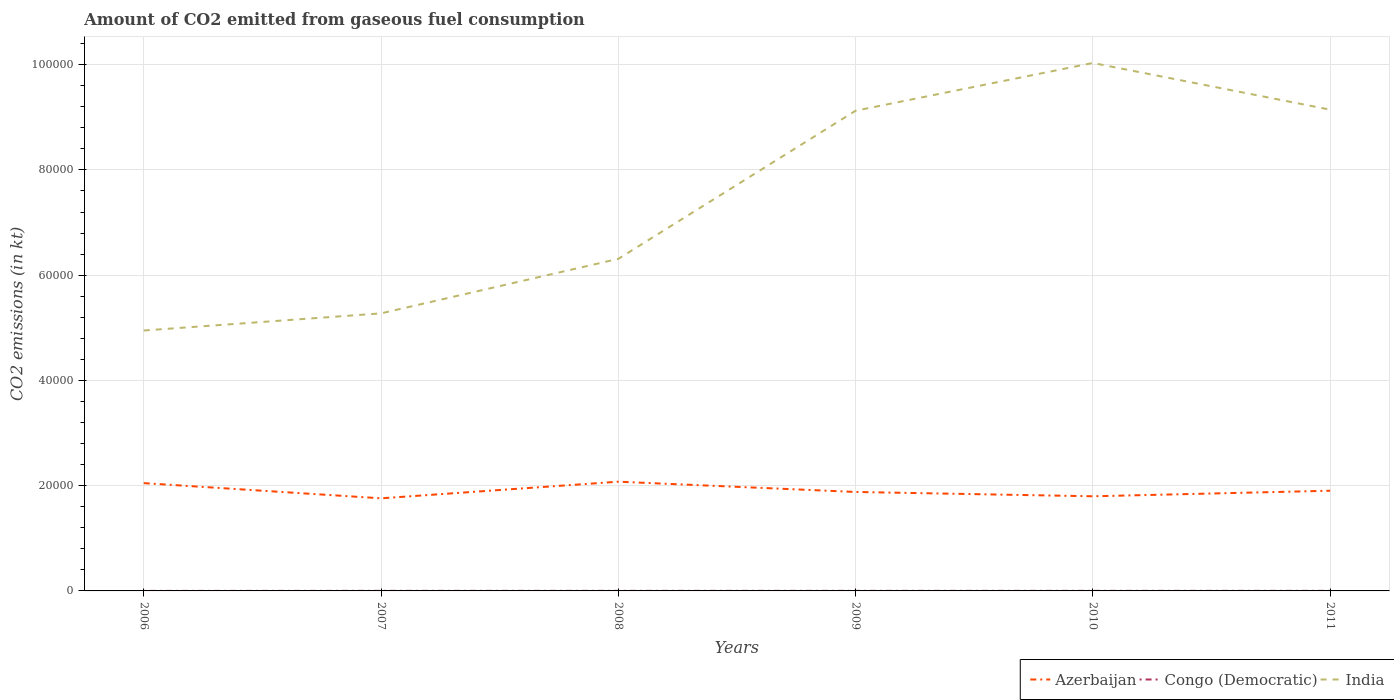How many different coloured lines are there?
Give a very brief answer. 3. Is the number of lines equal to the number of legend labels?
Offer a very short reply. Yes. Across all years, what is the maximum amount of CO2 emitted in India?
Your answer should be compact. 4.95e+04. In which year was the amount of CO2 emitted in Congo (Democratic) maximum?
Your answer should be compact. 2006. What is the total amount of CO2 emitted in India in the graph?
Your answer should be compact. -4.20e+04. What is the difference between the highest and the second highest amount of CO2 emitted in Congo (Democratic)?
Give a very brief answer. 7.33. Are the values on the major ticks of Y-axis written in scientific E-notation?
Provide a short and direct response. No. Does the graph contain any zero values?
Your answer should be compact. No. Does the graph contain grids?
Give a very brief answer. Yes. Where does the legend appear in the graph?
Make the answer very short. Bottom right. How many legend labels are there?
Your answer should be very brief. 3. What is the title of the graph?
Make the answer very short. Amount of CO2 emitted from gaseous fuel consumption. Does "Sweden" appear as one of the legend labels in the graph?
Make the answer very short. No. What is the label or title of the Y-axis?
Your response must be concise. CO2 emissions (in kt). What is the CO2 emissions (in kt) in Azerbaijan in 2006?
Make the answer very short. 2.05e+04. What is the CO2 emissions (in kt) in Congo (Democratic) in 2006?
Ensure brevity in your answer.  7.33. What is the CO2 emissions (in kt) in India in 2006?
Provide a short and direct response. 4.95e+04. What is the CO2 emissions (in kt) in Azerbaijan in 2007?
Ensure brevity in your answer.  1.76e+04. What is the CO2 emissions (in kt) of Congo (Democratic) in 2007?
Your answer should be compact. 14.67. What is the CO2 emissions (in kt) of India in 2007?
Offer a very short reply. 5.27e+04. What is the CO2 emissions (in kt) of Azerbaijan in 2008?
Offer a very short reply. 2.08e+04. What is the CO2 emissions (in kt) in Congo (Democratic) in 2008?
Offer a terse response. 14.67. What is the CO2 emissions (in kt) in India in 2008?
Ensure brevity in your answer.  6.31e+04. What is the CO2 emissions (in kt) in Azerbaijan in 2009?
Your response must be concise. 1.88e+04. What is the CO2 emissions (in kt) in Congo (Democratic) in 2009?
Your answer should be compact. 14.67. What is the CO2 emissions (in kt) of India in 2009?
Offer a very short reply. 9.12e+04. What is the CO2 emissions (in kt) in Azerbaijan in 2010?
Provide a short and direct response. 1.80e+04. What is the CO2 emissions (in kt) in Congo (Democratic) in 2010?
Offer a very short reply. 14.67. What is the CO2 emissions (in kt) of India in 2010?
Give a very brief answer. 1.00e+05. What is the CO2 emissions (in kt) of Azerbaijan in 2011?
Your answer should be compact. 1.90e+04. What is the CO2 emissions (in kt) of Congo (Democratic) in 2011?
Your response must be concise. 14.67. What is the CO2 emissions (in kt) of India in 2011?
Offer a terse response. 9.14e+04. Across all years, what is the maximum CO2 emissions (in kt) in Azerbaijan?
Make the answer very short. 2.08e+04. Across all years, what is the maximum CO2 emissions (in kt) in Congo (Democratic)?
Make the answer very short. 14.67. Across all years, what is the maximum CO2 emissions (in kt) of India?
Ensure brevity in your answer.  1.00e+05. Across all years, what is the minimum CO2 emissions (in kt) of Azerbaijan?
Keep it short and to the point. 1.76e+04. Across all years, what is the minimum CO2 emissions (in kt) of Congo (Democratic)?
Make the answer very short. 7.33. Across all years, what is the minimum CO2 emissions (in kt) in India?
Give a very brief answer. 4.95e+04. What is the total CO2 emissions (in kt) of Azerbaijan in the graph?
Offer a very short reply. 1.15e+05. What is the total CO2 emissions (in kt) of Congo (Democratic) in the graph?
Your answer should be compact. 80.67. What is the total CO2 emissions (in kt) in India in the graph?
Your response must be concise. 4.48e+05. What is the difference between the CO2 emissions (in kt) in Azerbaijan in 2006 and that in 2007?
Provide a succinct answer. 2889.6. What is the difference between the CO2 emissions (in kt) of Congo (Democratic) in 2006 and that in 2007?
Your answer should be compact. -7.33. What is the difference between the CO2 emissions (in kt) of India in 2006 and that in 2007?
Your answer should be very brief. -3256.3. What is the difference between the CO2 emissions (in kt) in Azerbaijan in 2006 and that in 2008?
Offer a very short reply. -271.36. What is the difference between the CO2 emissions (in kt) in Congo (Democratic) in 2006 and that in 2008?
Make the answer very short. -7.33. What is the difference between the CO2 emissions (in kt) of India in 2006 and that in 2008?
Ensure brevity in your answer.  -1.36e+04. What is the difference between the CO2 emissions (in kt) of Azerbaijan in 2006 and that in 2009?
Your answer should be compact. 1679.49. What is the difference between the CO2 emissions (in kt) of Congo (Democratic) in 2006 and that in 2009?
Offer a very short reply. -7.33. What is the difference between the CO2 emissions (in kt) in India in 2006 and that in 2009?
Give a very brief answer. -4.18e+04. What is the difference between the CO2 emissions (in kt) of Azerbaijan in 2006 and that in 2010?
Provide a succinct answer. 2500.89. What is the difference between the CO2 emissions (in kt) of Congo (Democratic) in 2006 and that in 2010?
Give a very brief answer. -7.33. What is the difference between the CO2 emissions (in kt) of India in 2006 and that in 2010?
Provide a succinct answer. -5.08e+04. What is the difference between the CO2 emissions (in kt) in Azerbaijan in 2006 and that in 2011?
Your response must be concise. 1444.8. What is the difference between the CO2 emissions (in kt) of Congo (Democratic) in 2006 and that in 2011?
Give a very brief answer. -7.33. What is the difference between the CO2 emissions (in kt) in India in 2006 and that in 2011?
Give a very brief answer. -4.20e+04. What is the difference between the CO2 emissions (in kt) in Azerbaijan in 2007 and that in 2008?
Offer a terse response. -3160.95. What is the difference between the CO2 emissions (in kt) of India in 2007 and that in 2008?
Keep it short and to the point. -1.04e+04. What is the difference between the CO2 emissions (in kt) of Azerbaijan in 2007 and that in 2009?
Offer a terse response. -1210.11. What is the difference between the CO2 emissions (in kt) of Congo (Democratic) in 2007 and that in 2009?
Provide a succinct answer. 0. What is the difference between the CO2 emissions (in kt) in India in 2007 and that in 2009?
Offer a terse response. -3.85e+04. What is the difference between the CO2 emissions (in kt) in Azerbaijan in 2007 and that in 2010?
Keep it short and to the point. -388.7. What is the difference between the CO2 emissions (in kt) in Congo (Democratic) in 2007 and that in 2010?
Your response must be concise. 0. What is the difference between the CO2 emissions (in kt) in India in 2007 and that in 2010?
Keep it short and to the point. -4.76e+04. What is the difference between the CO2 emissions (in kt) in Azerbaijan in 2007 and that in 2011?
Ensure brevity in your answer.  -1444.8. What is the difference between the CO2 emissions (in kt) in Congo (Democratic) in 2007 and that in 2011?
Ensure brevity in your answer.  0. What is the difference between the CO2 emissions (in kt) of India in 2007 and that in 2011?
Ensure brevity in your answer.  -3.87e+04. What is the difference between the CO2 emissions (in kt) of Azerbaijan in 2008 and that in 2009?
Give a very brief answer. 1950.84. What is the difference between the CO2 emissions (in kt) of Congo (Democratic) in 2008 and that in 2009?
Provide a succinct answer. 0. What is the difference between the CO2 emissions (in kt) in India in 2008 and that in 2009?
Ensure brevity in your answer.  -2.81e+04. What is the difference between the CO2 emissions (in kt) in Azerbaijan in 2008 and that in 2010?
Make the answer very short. 2772.25. What is the difference between the CO2 emissions (in kt) of India in 2008 and that in 2010?
Provide a succinct answer. -3.72e+04. What is the difference between the CO2 emissions (in kt) of Azerbaijan in 2008 and that in 2011?
Give a very brief answer. 1716.16. What is the difference between the CO2 emissions (in kt) in India in 2008 and that in 2011?
Offer a terse response. -2.83e+04. What is the difference between the CO2 emissions (in kt) of Azerbaijan in 2009 and that in 2010?
Your answer should be very brief. 821.41. What is the difference between the CO2 emissions (in kt) of India in 2009 and that in 2010?
Provide a succinct answer. -9072.16. What is the difference between the CO2 emissions (in kt) in Azerbaijan in 2009 and that in 2011?
Provide a short and direct response. -234.69. What is the difference between the CO2 emissions (in kt) in India in 2009 and that in 2011?
Provide a succinct answer. -198.02. What is the difference between the CO2 emissions (in kt) of Azerbaijan in 2010 and that in 2011?
Your answer should be very brief. -1056.1. What is the difference between the CO2 emissions (in kt) of Congo (Democratic) in 2010 and that in 2011?
Offer a very short reply. 0. What is the difference between the CO2 emissions (in kt) in India in 2010 and that in 2011?
Give a very brief answer. 8874.14. What is the difference between the CO2 emissions (in kt) in Azerbaijan in 2006 and the CO2 emissions (in kt) in Congo (Democratic) in 2007?
Offer a terse response. 2.05e+04. What is the difference between the CO2 emissions (in kt) of Azerbaijan in 2006 and the CO2 emissions (in kt) of India in 2007?
Give a very brief answer. -3.23e+04. What is the difference between the CO2 emissions (in kt) of Congo (Democratic) in 2006 and the CO2 emissions (in kt) of India in 2007?
Ensure brevity in your answer.  -5.27e+04. What is the difference between the CO2 emissions (in kt) in Azerbaijan in 2006 and the CO2 emissions (in kt) in Congo (Democratic) in 2008?
Offer a terse response. 2.05e+04. What is the difference between the CO2 emissions (in kt) in Azerbaijan in 2006 and the CO2 emissions (in kt) in India in 2008?
Offer a terse response. -4.26e+04. What is the difference between the CO2 emissions (in kt) in Congo (Democratic) in 2006 and the CO2 emissions (in kt) in India in 2008?
Provide a short and direct response. -6.31e+04. What is the difference between the CO2 emissions (in kt) in Azerbaijan in 2006 and the CO2 emissions (in kt) in Congo (Democratic) in 2009?
Offer a terse response. 2.05e+04. What is the difference between the CO2 emissions (in kt) in Azerbaijan in 2006 and the CO2 emissions (in kt) in India in 2009?
Your answer should be compact. -7.08e+04. What is the difference between the CO2 emissions (in kt) in Congo (Democratic) in 2006 and the CO2 emissions (in kt) in India in 2009?
Make the answer very short. -9.12e+04. What is the difference between the CO2 emissions (in kt) of Azerbaijan in 2006 and the CO2 emissions (in kt) of Congo (Democratic) in 2010?
Your answer should be very brief. 2.05e+04. What is the difference between the CO2 emissions (in kt) of Azerbaijan in 2006 and the CO2 emissions (in kt) of India in 2010?
Keep it short and to the point. -7.98e+04. What is the difference between the CO2 emissions (in kt) of Congo (Democratic) in 2006 and the CO2 emissions (in kt) of India in 2010?
Provide a succinct answer. -1.00e+05. What is the difference between the CO2 emissions (in kt) of Azerbaijan in 2006 and the CO2 emissions (in kt) of Congo (Democratic) in 2011?
Give a very brief answer. 2.05e+04. What is the difference between the CO2 emissions (in kt) in Azerbaijan in 2006 and the CO2 emissions (in kt) in India in 2011?
Your response must be concise. -7.10e+04. What is the difference between the CO2 emissions (in kt) in Congo (Democratic) in 2006 and the CO2 emissions (in kt) in India in 2011?
Provide a short and direct response. -9.14e+04. What is the difference between the CO2 emissions (in kt) in Azerbaijan in 2007 and the CO2 emissions (in kt) in Congo (Democratic) in 2008?
Offer a terse response. 1.76e+04. What is the difference between the CO2 emissions (in kt) of Azerbaijan in 2007 and the CO2 emissions (in kt) of India in 2008?
Your response must be concise. -4.55e+04. What is the difference between the CO2 emissions (in kt) in Congo (Democratic) in 2007 and the CO2 emissions (in kt) in India in 2008?
Your response must be concise. -6.31e+04. What is the difference between the CO2 emissions (in kt) in Azerbaijan in 2007 and the CO2 emissions (in kt) in Congo (Democratic) in 2009?
Give a very brief answer. 1.76e+04. What is the difference between the CO2 emissions (in kt) of Azerbaijan in 2007 and the CO2 emissions (in kt) of India in 2009?
Give a very brief answer. -7.37e+04. What is the difference between the CO2 emissions (in kt) in Congo (Democratic) in 2007 and the CO2 emissions (in kt) in India in 2009?
Your answer should be very brief. -9.12e+04. What is the difference between the CO2 emissions (in kt) in Azerbaijan in 2007 and the CO2 emissions (in kt) in Congo (Democratic) in 2010?
Keep it short and to the point. 1.76e+04. What is the difference between the CO2 emissions (in kt) in Azerbaijan in 2007 and the CO2 emissions (in kt) in India in 2010?
Ensure brevity in your answer.  -8.27e+04. What is the difference between the CO2 emissions (in kt) of Congo (Democratic) in 2007 and the CO2 emissions (in kt) of India in 2010?
Your answer should be compact. -1.00e+05. What is the difference between the CO2 emissions (in kt) in Azerbaijan in 2007 and the CO2 emissions (in kt) in Congo (Democratic) in 2011?
Provide a short and direct response. 1.76e+04. What is the difference between the CO2 emissions (in kt) in Azerbaijan in 2007 and the CO2 emissions (in kt) in India in 2011?
Offer a very short reply. -7.38e+04. What is the difference between the CO2 emissions (in kt) of Congo (Democratic) in 2007 and the CO2 emissions (in kt) of India in 2011?
Your answer should be compact. -9.14e+04. What is the difference between the CO2 emissions (in kt) in Azerbaijan in 2008 and the CO2 emissions (in kt) in Congo (Democratic) in 2009?
Make the answer very short. 2.07e+04. What is the difference between the CO2 emissions (in kt) of Azerbaijan in 2008 and the CO2 emissions (in kt) of India in 2009?
Your response must be concise. -7.05e+04. What is the difference between the CO2 emissions (in kt) of Congo (Democratic) in 2008 and the CO2 emissions (in kt) of India in 2009?
Ensure brevity in your answer.  -9.12e+04. What is the difference between the CO2 emissions (in kt) of Azerbaijan in 2008 and the CO2 emissions (in kt) of Congo (Democratic) in 2010?
Make the answer very short. 2.07e+04. What is the difference between the CO2 emissions (in kt) in Azerbaijan in 2008 and the CO2 emissions (in kt) in India in 2010?
Keep it short and to the point. -7.96e+04. What is the difference between the CO2 emissions (in kt) of Congo (Democratic) in 2008 and the CO2 emissions (in kt) of India in 2010?
Ensure brevity in your answer.  -1.00e+05. What is the difference between the CO2 emissions (in kt) of Azerbaijan in 2008 and the CO2 emissions (in kt) of Congo (Democratic) in 2011?
Provide a short and direct response. 2.07e+04. What is the difference between the CO2 emissions (in kt) of Azerbaijan in 2008 and the CO2 emissions (in kt) of India in 2011?
Offer a terse response. -7.07e+04. What is the difference between the CO2 emissions (in kt) of Congo (Democratic) in 2008 and the CO2 emissions (in kt) of India in 2011?
Offer a very short reply. -9.14e+04. What is the difference between the CO2 emissions (in kt) in Azerbaijan in 2009 and the CO2 emissions (in kt) in Congo (Democratic) in 2010?
Ensure brevity in your answer.  1.88e+04. What is the difference between the CO2 emissions (in kt) in Azerbaijan in 2009 and the CO2 emissions (in kt) in India in 2010?
Your answer should be compact. -8.15e+04. What is the difference between the CO2 emissions (in kt) of Congo (Democratic) in 2009 and the CO2 emissions (in kt) of India in 2010?
Provide a succinct answer. -1.00e+05. What is the difference between the CO2 emissions (in kt) in Azerbaijan in 2009 and the CO2 emissions (in kt) in Congo (Democratic) in 2011?
Your answer should be very brief. 1.88e+04. What is the difference between the CO2 emissions (in kt) of Azerbaijan in 2009 and the CO2 emissions (in kt) of India in 2011?
Provide a short and direct response. -7.26e+04. What is the difference between the CO2 emissions (in kt) in Congo (Democratic) in 2009 and the CO2 emissions (in kt) in India in 2011?
Make the answer very short. -9.14e+04. What is the difference between the CO2 emissions (in kt) in Azerbaijan in 2010 and the CO2 emissions (in kt) in Congo (Democratic) in 2011?
Ensure brevity in your answer.  1.80e+04. What is the difference between the CO2 emissions (in kt) of Azerbaijan in 2010 and the CO2 emissions (in kt) of India in 2011?
Keep it short and to the point. -7.35e+04. What is the difference between the CO2 emissions (in kt) in Congo (Democratic) in 2010 and the CO2 emissions (in kt) in India in 2011?
Give a very brief answer. -9.14e+04. What is the average CO2 emissions (in kt) of Azerbaijan per year?
Your response must be concise. 1.91e+04. What is the average CO2 emissions (in kt) of Congo (Democratic) per year?
Your response must be concise. 13.45. What is the average CO2 emissions (in kt) of India per year?
Your response must be concise. 7.47e+04. In the year 2006, what is the difference between the CO2 emissions (in kt) of Azerbaijan and CO2 emissions (in kt) of Congo (Democratic)?
Offer a terse response. 2.05e+04. In the year 2006, what is the difference between the CO2 emissions (in kt) of Azerbaijan and CO2 emissions (in kt) of India?
Offer a terse response. -2.90e+04. In the year 2006, what is the difference between the CO2 emissions (in kt) of Congo (Democratic) and CO2 emissions (in kt) of India?
Ensure brevity in your answer.  -4.95e+04. In the year 2007, what is the difference between the CO2 emissions (in kt) in Azerbaijan and CO2 emissions (in kt) in Congo (Democratic)?
Offer a very short reply. 1.76e+04. In the year 2007, what is the difference between the CO2 emissions (in kt) of Azerbaijan and CO2 emissions (in kt) of India?
Provide a short and direct response. -3.51e+04. In the year 2007, what is the difference between the CO2 emissions (in kt) of Congo (Democratic) and CO2 emissions (in kt) of India?
Offer a terse response. -5.27e+04. In the year 2008, what is the difference between the CO2 emissions (in kt) of Azerbaijan and CO2 emissions (in kt) of Congo (Democratic)?
Keep it short and to the point. 2.07e+04. In the year 2008, what is the difference between the CO2 emissions (in kt) in Azerbaijan and CO2 emissions (in kt) in India?
Ensure brevity in your answer.  -4.23e+04. In the year 2008, what is the difference between the CO2 emissions (in kt) in Congo (Democratic) and CO2 emissions (in kt) in India?
Your response must be concise. -6.31e+04. In the year 2009, what is the difference between the CO2 emissions (in kt) of Azerbaijan and CO2 emissions (in kt) of Congo (Democratic)?
Provide a succinct answer. 1.88e+04. In the year 2009, what is the difference between the CO2 emissions (in kt) of Azerbaijan and CO2 emissions (in kt) of India?
Give a very brief answer. -7.24e+04. In the year 2009, what is the difference between the CO2 emissions (in kt) in Congo (Democratic) and CO2 emissions (in kt) in India?
Ensure brevity in your answer.  -9.12e+04. In the year 2010, what is the difference between the CO2 emissions (in kt) in Azerbaijan and CO2 emissions (in kt) in Congo (Democratic)?
Offer a very short reply. 1.80e+04. In the year 2010, what is the difference between the CO2 emissions (in kt) of Azerbaijan and CO2 emissions (in kt) of India?
Ensure brevity in your answer.  -8.23e+04. In the year 2010, what is the difference between the CO2 emissions (in kt) in Congo (Democratic) and CO2 emissions (in kt) in India?
Keep it short and to the point. -1.00e+05. In the year 2011, what is the difference between the CO2 emissions (in kt) of Azerbaijan and CO2 emissions (in kt) of Congo (Democratic)?
Your answer should be very brief. 1.90e+04. In the year 2011, what is the difference between the CO2 emissions (in kt) of Azerbaijan and CO2 emissions (in kt) of India?
Make the answer very short. -7.24e+04. In the year 2011, what is the difference between the CO2 emissions (in kt) of Congo (Democratic) and CO2 emissions (in kt) of India?
Your answer should be compact. -9.14e+04. What is the ratio of the CO2 emissions (in kt) in Azerbaijan in 2006 to that in 2007?
Provide a short and direct response. 1.16. What is the ratio of the CO2 emissions (in kt) in Congo (Democratic) in 2006 to that in 2007?
Give a very brief answer. 0.5. What is the ratio of the CO2 emissions (in kt) in India in 2006 to that in 2007?
Provide a succinct answer. 0.94. What is the ratio of the CO2 emissions (in kt) of Azerbaijan in 2006 to that in 2008?
Keep it short and to the point. 0.99. What is the ratio of the CO2 emissions (in kt) of India in 2006 to that in 2008?
Ensure brevity in your answer.  0.78. What is the ratio of the CO2 emissions (in kt) of Azerbaijan in 2006 to that in 2009?
Give a very brief answer. 1.09. What is the ratio of the CO2 emissions (in kt) in Congo (Democratic) in 2006 to that in 2009?
Your response must be concise. 0.5. What is the ratio of the CO2 emissions (in kt) of India in 2006 to that in 2009?
Your response must be concise. 0.54. What is the ratio of the CO2 emissions (in kt) of Azerbaijan in 2006 to that in 2010?
Ensure brevity in your answer.  1.14. What is the ratio of the CO2 emissions (in kt) of India in 2006 to that in 2010?
Offer a very short reply. 0.49. What is the ratio of the CO2 emissions (in kt) of Azerbaijan in 2006 to that in 2011?
Give a very brief answer. 1.08. What is the ratio of the CO2 emissions (in kt) of Congo (Democratic) in 2006 to that in 2011?
Your response must be concise. 0.5. What is the ratio of the CO2 emissions (in kt) of India in 2006 to that in 2011?
Make the answer very short. 0.54. What is the ratio of the CO2 emissions (in kt) in Azerbaijan in 2007 to that in 2008?
Keep it short and to the point. 0.85. What is the ratio of the CO2 emissions (in kt) of India in 2007 to that in 2008?
Provide a short and direct response. 0.84. What is the ratio of the CO2 emissions (in kt) of Azerbaijan in 2007 to that in 2009?
Offer a very short reply. 0.94. What is the ratio of the CO2 emissions (in kt) in Congo (Democratic) in 2007 to that in 2009?
Provide a succinct answer. 1. What is the ratio of the CO2 emissions (in kt) in India in 2007 to that in 2009?
Provide a short and direct response. 0.58. What is the ratio of the CO2 emissions (in kt) of Azerbaijan in 2007 to that in 2010?
Give a very brief answer. 0.98. What is the ratio of the CO2 emissions (in kt) of Congo (Democratic) in 2007 to that in 2010?
Your answer should be very brief. 1. What is the ratio of the CO2 emissions (in kt) in India in 2007 to that in 2010?
Provide a short and direct response. 0.53. What is the ratio of the CO2 emissions (in kt) of Azerbaijan in 2007 to that in 2011?
Offer a terse response. 0.92. What is the ratio of the CO2 emissions (in kt) in Congo (Democratic) in 2007 to that in 2011?
Make the answer very short. 1. What is the ratio of the CO2 emissions (in kt) of India in 2007 to that in 2011?
Your response must be concise. 0.58. What is the ratio of the CO2 emissions (in kt) in Azerbaijan in 2008 to that in 2009?
Offer a terse response. 1.1. What is the ratio of the CO2 emissions (in kt) in India in 2008 to that in 2009?
Give a very brief answer. 0.69. What is the ratio of the CO2 emissions (in kt) in Azerbaijan in 2008 to that in 2010?
Your answer should be compact. 1.15. What is the ratio of the CO2 emissions (in kt) of Congo (Democratic) in 2008 to that in 2010?
Keep it short and to the point. 1. What is the ratio of the CO2 emissions (in kt) in India in 2008 to that in 2010?
Your answer should be compact. 0.63. What is the ratio of the CO2 emissions (in kt) in Azerbaijan in 2008 to that in 2011?
Keep it short and to the point. 1.09. What is the ratio of the CO2 emissions (in kt) in Congo (Democratic) in 2008 to that in 2011?
Offer a very short reply. 1. What is the ratio of the CO2 emissions (in kt) of India in 2008 to that in 2011?
Your answer should be very brief. 0.69. What is the ratio of the CO2 emissions (in kt) in Azerbaijan in 2009 to that in 2010?
Ensure brevity in your answer.  1.05. What is the ratio of the CO2 emissions (in kt) in India in 2009 to that in 2010?
Provide a succinct answer. 0.91. What is the ratio of the CO2 emissions (in kt) of India in 2009 to that in 2011?
Keep it short and to the point. 1. What is the ratio of the CO2 emissions (in kt) in Azerbaijan in 2010 to that in 2011?
Your answer should be very brief. 0.94. What is the ratio of the CO2 emissions (in kt) in Congo (Democratic) in 2010 to that in 2011?
Give a very brief answer. 1. What is the ratio of the CO2 emissions (in kt) in India in 2010 to that in 2011?
Your answer should be compact. 1.1. What is the difference between the highest and the second highest CO2 emissions (in kt) of Azerbaijan?
Make the answer very short. 271.36. What is the difference between the highest and the second highest CO2 emissions (in kt) in Congo (Democratic)?
Offer a terse response. 0. What is the difference between the highest and the second highest CO2 emissions (in kt) in India?
Provide a succinct answer. 8874.14. What is the difference between the highest and the lowest CO2 emissions (in kt) in Azerbaijan?
Your answer should be compact. 3160.95. What is the difference between the highest and the lowest CO2 emissions (in kt) in Congo (Democratic)?
Ensure brevity in your answer.  7.33. What is the difference between the highest and the lowest CO2 emissions (in kt) of India?
Provide a short and direct response. 5.08e+04. 